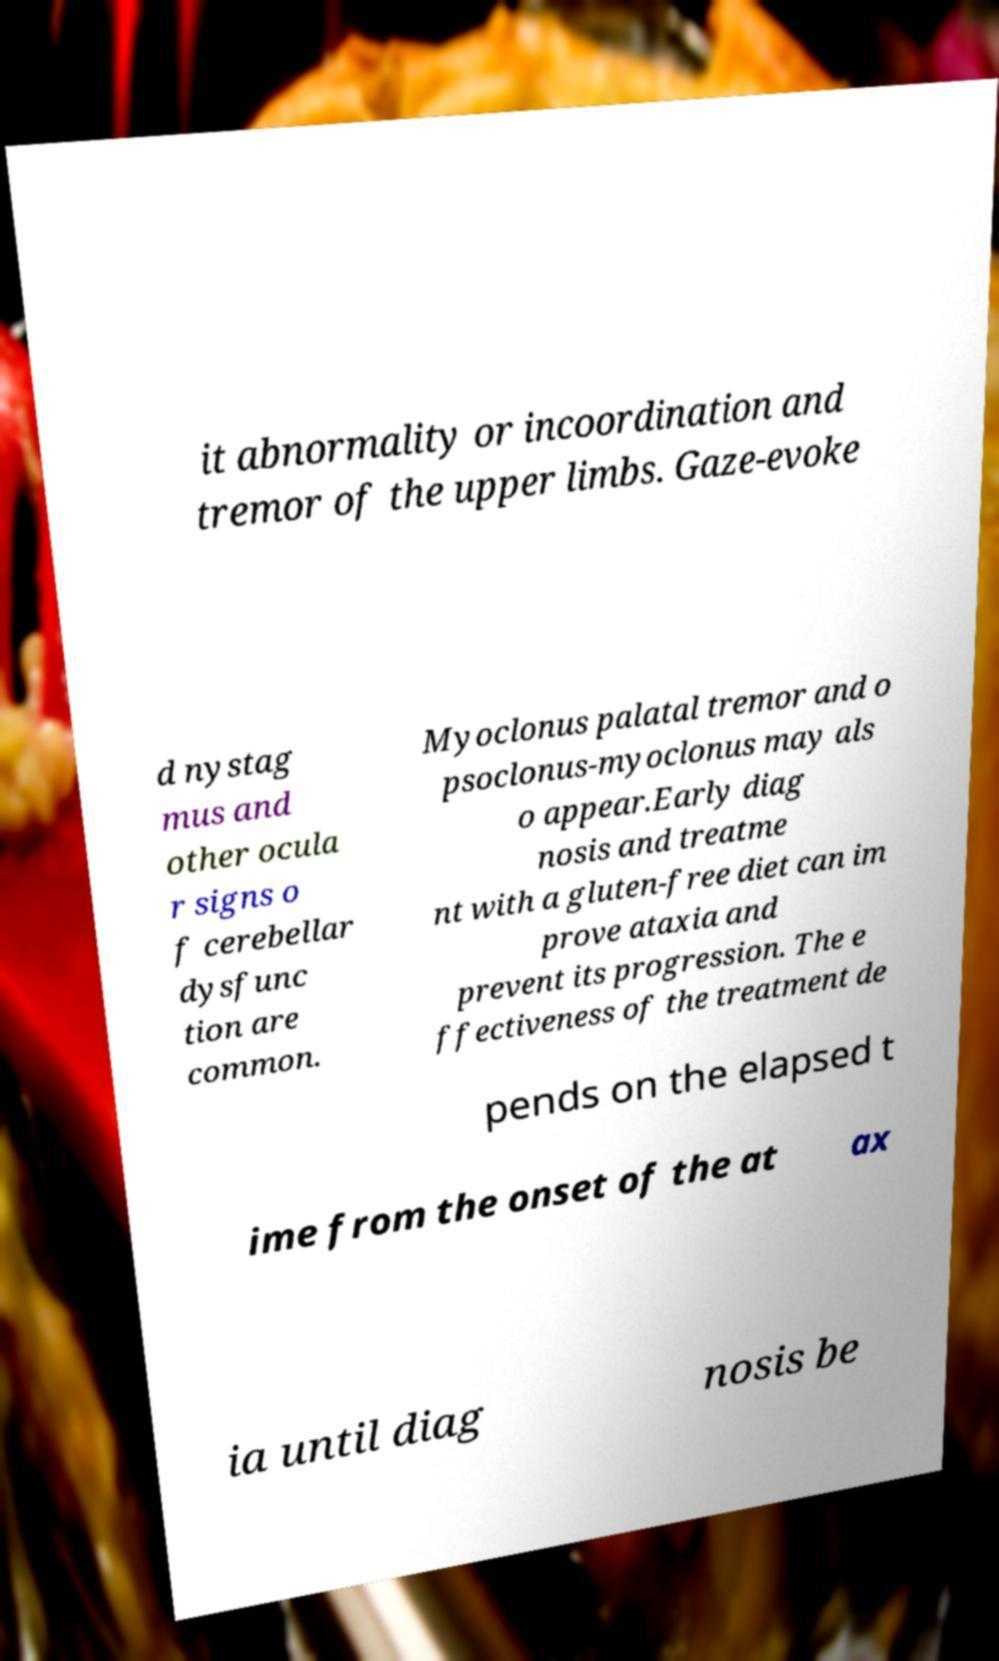I need the written content from this picture converted into text. Can you do that? it abnormality or incoordination and tremor of the upper limbs. Gaze-evoke d nystag mus and other ocula r signs o f cerebellar dysfunc tion are common. Myoclonus palatal tremor and o psoclonus-myoclonus may als o appear.Early diag nosis and treatme nt with a gluten-free diet can im prove ataxia and prevent its progression. The e ffectiveness of the treatment de pends on the elapsed t ime from the onset of the at ax ia until diag nosis be 